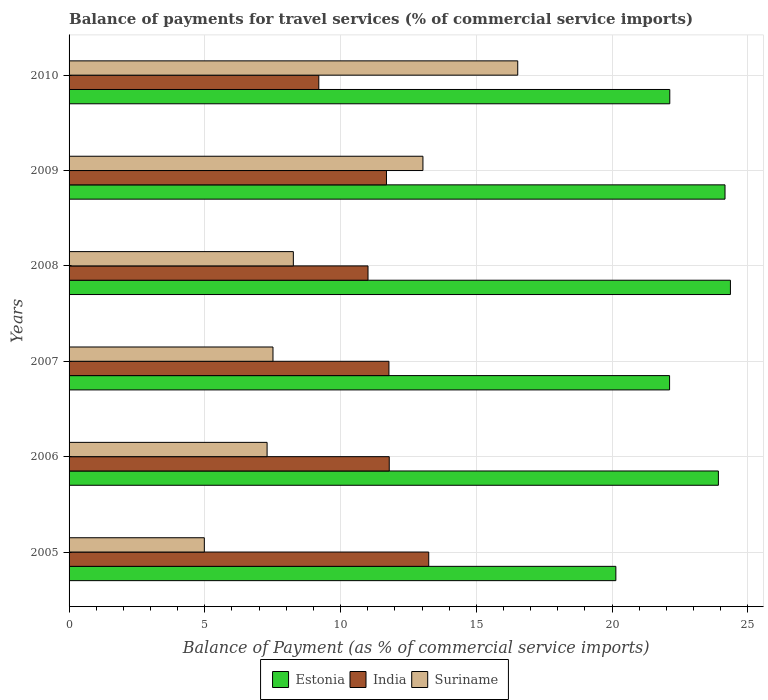Are the number of bars on each tick of the Y-axis equal?
Give a very brief answer. Yes. How many bars are there on the 4th tick from the bottom?
Ensure brevity in your answer.  3. What is the label of the 5th group of bars from the top?
Provide a short and direct response. 2006. What is the balance of payments for travel services in Suriname in 2007?
Ensure brevity in your answer.  7.51. Across all years, what is the maximum balance of payments for travel services in Estonia?
Offer a terse response. 24.36. Across all years, what is the minimum balance of payments for travel services in Suriname?
Provide a short and direct response. 4.98. In which year was the balance of payments for travel services in Suriname minimum?
Your answer should be very brief. 2005. What is the total balance of payments for travel services in Estonia in the graph?
Ensure brevity in your answer.  136.83. What is the difference between the balance of payments for travel services in Estonia in 2006 and that in 2007?
Make the answer very short. 1.8. What is the difference between the balance of payments for travel services in Suriname in 2006 and the balance of payments for travel services in Estonia in 2007?
Provide a short and direct response. -14.83. What is the average balance of payments for travel services in Suriname per year?
Your answer should be very brief. 9.6. In the year 2010, what is the difference between the balance of payments for travel services in Estonia and balance of payments for travel services in India?
Keep it short and to the point. 12.93. In how many years, is the balance of payments for travel services in Suriname greater than 15 %?
Give a very brief answer. 1. What is the ratio of the balance of payments for travel services in Suriname in 2007 to that in 2009?
Offer a very short reply. 0.58. Is the balance of payments for travel services in Suriname in 2009 less than that in 2010?
Provide a succinct answer. Yes. What is the difference between the highest and the second highest balance of payments for travel services in Suriname?
Your answer should be very brief. 3.49. What is the difference between the highest and the lowest balance of payments for travel services in Suriname?
Offer a very short reply. 11.54. Is the sum of the balance of payments for travel services in India in 2007 and 2008 greater than the maximum balance of payments for travel services in Suriname across all years?
Offer a terse response. Yes. What does the 3rd bar from the top in 2010 represents?
Offer a terse response. Estonia. What does the 3rd bar from the bottom in 2010 represents?
Give a very brief answer. Suriname. How many bars are there?
Offer a terse response. 18. Are all the bars in the graph horizontal?
Your answer should be compact. Yes. Does the graph contain grids?
Provide a short and direct response. Yes. Where does the legend appear in the graph?
Offer a terse response. Bottom center. What is the title of the graph?
Make the answer very short. Balance of payments for travel services (% of commercial service imports). What is the label or title of the X-axis?
Ensure brevity in your answer.  Balance of Payment (as % of commercial service imports). What is the label or title of the Y-axis?
Make the answer very short. Years. What is the Balance of Payment (as % of commercial service imports) of Estonia in 2005?
Ensure brevity in your answer.  20.14. What is the Balance of Payment (as % of commercial service imports) in India in 2005?
Keep it short and to the point. 13.25. What is the Balance of Payment (as % of commercial service imports) of Suriname in 2005?
Your answer should be compact. 4.98. What is the Balance of Payment (as % of commercial service imports) of Estonia in 2006?
Your answer should be compact. 23.92. What is the Balance of Payment (as % of commercial service imports) in India in 2006?
Offer a terse response. 11.79. What is the Balance of Payment (as % of commercial service imports) of Suriname in 2006?
Your answer should be compact. 7.29. What is the Balance of Payment (as % of commercial service imports) in Estonia in 2007?
Your answer should be compact. 22.12. What is the Balance of Payment (as % of commercial service imports) of India in 2007?
Offer a terse response. 11.78. What is the Balance of Payment (as % of commercial service imports) of Suriname in 2007?
Ensure brevity in your answer.  7.51. What is the Balance of Payment (as % of commercial service imports) of Estonia in 2008?
Give a very brief answer. 24.36. What is the Balance of Payment (as % of commercial service imports) of India in 2008?
Give a very brief answer. 11.01. What is the Balance of Payment (as % of commercial service imports) in Suriname in 2008?
Your answer should be compact. 8.26. What is the Balance of Payment (as % of commercial service imports) in Estonia in 2009?
Keep it short and to the point. 24.16. What is the Balance of Payment (as % of commercial service imports) in India in 2009?
Make the answer very short. 11.69. What is the Balance of Payment (as % of commercial service imports) in Suriname in 2009?
Ensure brevity in your answer.  13.03. What is the Balance of Payment (as % of commercial service imports) in Estonia in 2010?
Ensure brevity in your answer.  22.13. What is the Balance of Payment (as % of commercial service imports) of India in 2010?
Offer a terse response. 9.2. What is the Balance of Payment (as % of commercial service imports) in Suriname in 2010?
Give a very brief answer. 16.53. Across all years, what is the maximum Balance of Payment (as % of commercial service imports) in Estonia?
Ensure brevity in your answer.  24.36. Across all years, what is the maximum Balance of Payment (as % of commercial service imports) in India?
Provide a succinct answer. 13.25. Across all years, what is the maximum Balance of Payment (as % of commercial service imports) of Suriname?
Ensure brevity in your answer.  16.53. Across all years, what is the minimum Balance of Payment (as % of commercial service imports) of Estonia?
Your answer should be compact. 20.14. Across all years, what is the minimum Balance of Payment (as % of commercial service imports) in India?
Offer a terse response. 9.2. Across all years, what is the minimum Balance of Payment (as % of commercial service imports) in Suriname?
Your answer should be compact. 4.98. What is the total Balance of Payment (as % of commercial service imports) in Estonia in the graph?
Offer a terse response. 136.83. What is the total Balance of Payment (as % of commercial service imports) of India in the graph?
Offer a terse response. 68.72. What is the total Balance of Payment (as % of commercial service imports) in Suriname in the graph?
Provide a short and direct response. 57.61. What is the difference between the Balance of Payment (as % of commercial service imports) of Estonia in 2005 and that in 2006?
Provide a short and direct response. -3.78. What is the difference between the Balance of Payment (as % of commercial service imports) of India in 2005 and that in 2006?
Your response must be concise. 1.45. What is the difference between the Balance of Payment (as % of commercial service imports) in Suriname in 2005 and that in 2006?
Keep it short and to the point. -2.31. What is the difference between the Balance of Payment (as % of commercial service imports) in Estonia in 2005 and that in 2007?
Make the answer very short. -1.98. What is the difference between the Balance of Payment (as % of commercial service imports) of India in 2005 and that in 2007?
Provide a succinct answer. 1.47. What is the difference between the Balance of Payment (as % of commercial service imports) of Suriname in 2005 and that in 2007?
Your answer should be very brief. -2.53. What is the difference between the Balance of Payment (as % of commercial service imports) in Estonia in 2005 and that in 2008?
Your answer should be very brief. -4.22. What is the difference between the Balance of Payment (as % of commercial service imports) of India in 2005 and that in 2008?
Your answer should be compact. 2.24. What is the difference between the Balance of Payment (as % of commercial service imports) of Suriname in 2005 and that in 2008?
Ensure brevity in your answer.  -3.28. What is the difference between the Balance of Payment (as % of commercial service imports) in Estonia in 2005 and that in 2009?
Your answer should be very brief. -4.02. What is the difference between the Balance of Payment (as % of commercial service imports) of India in 2005 and that in 2009?
Ensure brevity in your answer.  1.56. What is the difference between the Balance of Payment (as % of commercial service imports) of Suriname in 2005 and that in 2009?
Provide a succinct answer. -8.05. What is the difference between the Balance of Payment (as % of commercial service imports) in Estonia in 2005 and that in 2010?
Provide a short and direct response. -1.99. What is the difference between the Balance of Payment (as % of commercial service imports) of India in 2005 and that in 2010?
Give a very brief answer. 4.05. What is the difference between the Balance of Payment (as % of commercial service imports) in Suriname in 2005 and that in 2010?
Offer a very short reply. -11.54. What is the difference between the Balance of Payment (as % of commercial service imports) in Estonia in 2006 and that in 2007?
Offer a terse response. 1.8. What is the difference between the Balance of Payment (as % of commercial service imports) in India in 2006 and that in 2007?
Provide a succinct answer. 0.01. What is the difference between the Balance of Payment (as % of commercial service imports) of Suriname in 2006 and that in 2007?
Make the answer very short. -0.22. What is the difference between the Balance of Payment (as % of commercial service imports) in Estonia in 2006 and that in 2008?
Keep it short and to the point. -0.44. What is the difference between the Balance of Payment (as % of commercial service imports) of India in 2006 and that in 2008?
Offer a terse response. 0.78. What is the difference between the Balance of Payment (as % of commercial service imports) in Suriname in 2006 and that in 2008?
Your answer should be very brief. -0.97. What is the difference between the Balance of Payment (as % of commercial service imports) of Estonia in 2006 and that in 2009?
Give a very brief answer. -0.24. What is the difference between the Balance of Payment (as % of commercial service imports) of India in 2006 and that in 2009?
Keep it short and to the point. 0.1. What is the difference between the Balance of Payment (as % of commercial service imports) in Suriname in 2006 and that in 2009?
Offer a very short reply. -5.74. What is the difference between the Balance of Payment (as % of commercial service imports) of Estonia in 2006 and that in 2010?
Provide a succinct answer. 1.79. What is the difference between the Balance of Payment (as % of commercial service imports) of India in 2006 and that in 2010?
Ensure brevity in your answer.  2.59. What is the difference between the Balance of Payment (as % of commercial service imports) in Suriname in 2006 and that in 2010?
Offer a terse response. -9.23. What is the difference between the Balance of Payment (as % of commercial service imports) in Estonia in 2007 and that in 2008?
Your response must be concise. -2.24. What is the difference between the Balance of Payment (as % of commercial service imports) of India in 2007 and that in 2008?
Your answer should be very brief. 0.77. What is the difference between the Balance of Payment (as % of commercial service imports) in Suriname in 2007 and that in 2008?
Ensure brevity in your answer.  -0.75. What is the difference between the Balance of Payment (as % of commercial service imports) of Estonia in 2007 and that in 2009?
Your answer should be very brief. -2.04. What is the difference between the Balance of Payment (as % of commercial service imports) in India in 2007 and that in 2009?
Your response must be concise. 0.09. What is the difference between the Balance of Payment (as % of commercial service imports) of Suriname in 2007 and that in 2009?
Provide a short and direct response. -5.52. What is the difference between the Balance of Payment (as % of commercial service imports) of Estonia in 2007 and that in 2010?
Your answer should be compact. -0.01. What is the difference between the Balance of Payment (as % of commercial service imports) in India in 2007 and that in 2010?
Keep it short and to the point. 2.58. What is the difference between the Balance of Payment (as % of commercial service imports) in Suriname in 2007 and that in 2010?
Your answer should be very brief. -9.02. What is the difference between the Balance of Payment (as % of commercial service imports) of Estonia in 2008 and that in 2009?
Offer a very short reply. 0.2. What is the difference between the Balance of Payment (as % of commercial service imports) of India in 2008 and that in 2009?
Give a very brief answer. -0.68. What is the difference between the Balance of Payment (as % of commercial service imports) of Suriname in 2008 and that in 2009?
Ensure brevity in your answer.  -4.77. What is the difference between the Balance of Payment (as % of commercial service imports) of Estonia in 2008 and that in 2010?
Your response must be concise. 2.23. What is the difference between the Balance of Payment (as % of commercial service imports) in India in 2008 and that in 2010?
Give a very brief answer. 1.81. What is the difference between the Balance of Payment (as % of commercial service imports) of Suriname in 2008 and that in 2010?
Make the answer very short. -8.27. What is the difference between the Balance of Payment (as % of commercial service imports) of Estonia in 2009 and that in 2010?
Give a very brief answer. 2.03. What is the difference between the Balance of Payment (as % of commercial service imports) of India in 2009 and that in 2010?
Offer a terse response. 2.49. What is the difference between the Balance of Payment (as % of commercial service imports) of Suriname in 2009 and that in 2010?
Offer a very short reply. -3.49. What is the difference between the Balance of Payment (as % of commercial service imports) of Estonia in 2005 and the Balance of Payment (as % of commercial service imports) of India in 2006?
Your response must be concise. 8.35. What is the difference between the Balance of Payment (as % of commercial service imports) in Estonia in 2005 and the Balance of Payment (as % of commercial service imports) in Suriname in 2006?
Provide a succinct answer. 12.85. What is the difference between the Balance of Payment (as % of commercial service imports) of India in 2005 and the Balance of Payment (as % of commercial service imports) of Suriname in 2006?
Your response must be concise. 5.95. What is the difference between the Balance of Payment (as % of commercial service imports) of Estonia in 2005 and the Balance of Payment (as % of commercial service imports) of India in 2007?
Make the answer very short. 8.36. What is the difference between the Balance of Payment (as % of commercial service imports) in Estonia in 2005 and the Balance of Payment (as % of commercial service imports) in Suriname in 2007?
Your answer should be compact. 12.63. What is the difference between the Balance of Payment (as % of commercial service imports) of India in 2005 and the Balance of Payment (as % of commercial service imports) of Suriname in 2007?
Make the answer very short. 5.74. What is the difference between the Balance of Payment (as % of commercial service imports) of Estonia in 2005 and the Balance of Payment (as % of commercial service imports) of India in 2008?
Your response must be concise. 9.13. What is the difference between the Balance of Payment (as % of commercial service imports) of Estonia in 2005 and the Balance of Payment (as % of commercial service imports) of Suriname in 2008?
Offer a terse response. 11.88. What is the difference between the Balance of Payment (as % of commercial service imports) in India in 2005 and the Balance of Payment (as % of commercial service imports) in Suriname in 2008?
Keep it short and to the point. 4.99. What is the difference between the Balance of Payment (as % of commercial service imports) of Estonia in 2005 and the Balance of Payment (as % of commercial service imports) of India in 2009?
Your answer should be very brief. 8.45. What is the difference between the Balance of Payment (as % of commercial service imports) in Estonia in 2005 and the Balance of Payment (as % of commercial service imports) in Suriname in 2009?
Offer a terse response. 7.11. What is the difference between the Balance of Payment (as % of commercial service imports) of India in 2005 and the Balance of Payment (as % of commercial service imports) of Suriname in 2009?
Provide a succinct answer. 0.21. What is the difference between the Balance of Payment (as % of commercial service imports) in Estonia in 2005 and the Balance of Payment (as % of commercial service imports) in India in 2010?
Ensure brevity in your answer.  10.94. What is the difference between the Balance of Payment (as % of commercial service imports) in Estonia in 2005 and the Balance of Payment (as % of commercial service imports) in Suriname in 2010?
Make the answer very short. 3.61. What is the difference between the Balance of Payment (as % of commercial service imports) in India in 2005 and the Balance of Payment (as % of commercial service imports) in Suriname in 2010?
Offer a very short reply. -3.28. What is the difference between the Balance of Payment (as % of commercial service imports) of Estonia in 2006 and the Balance of Payment (as % of commercial service imports) of India in 2007?
Ensure brevity in your answer.  12.14. What is the difference between the Balance of Payment (as % of commercial service imports) of Estonia in 2006 and the Balance of Payment (as % of commercial service imports) of Suriname in 2007?
Your answer should be compact. 16.41. What is the difference between the Balance of Payment (as % of commercial service imports) in India in 2006 and the Balance of Payment (as % of commercial service imports) in Suriname in 2007?
Offer a very short reply. 4.28. What is the difference between the Balance of Payment (as % of commercial service imports) in Estonia in 2006 and the Balance of Payment (as % of commercial service imports) in India in 2008?
Provide a short and direct response. 12.91. What is the difference between the Balance of Payment (as % of commercial service imports) in Estonia in 2006 and the Balance of Payment (as % of commercial service imports) in Suriname in 2008?
Your answer should be compact. 15.66. What is the difference between the Balance of Payment (as % of commercial service imports) of India in 2006 and the Balance of Payment (as % of commercial service imports) of Suriname in 2008?
Your response must be concise. 3.53. What is the difference between the Balance of Payment (as % of commercial service imports) in Estonia in 2006 and the Balance of Payment (as % of commercial service imports) in India in 2009?
Offer a very short reply. 12.23. What is the difference between the Balance of Payment (as % of commercial service imports) in Estonia in 2006 and the Balance of Payment (as % of commercial service imports) in Suriname in 2009?
Your answer should be very brief. 10.88. What is the difference between the Balance of Payment (as % of commercial service imports) in India in 2006 and the Balance of Payment (as % of commercial service imports) in Suriname in 2009?
Provide a succinct answer. -1.24. What is the difference between the Balance of Payment (as % of commercial service imports) of Estonia in 2006 and the Balance of Payment (as % of commercial service imports) of India in 2010?
Provide a succinct answer. 14.72. What is the difference between the Balance of Payment (as % of commercial service imports) in Estonia in 2006 and the Balance of Payment (as % of commercial service imports) in Suriname in 2010?
Ensure brevity in your answer.  7.39. What is the difference between the Balance of Payment (as % of commercial service imports) in India in 2006 and the Balance of Payment (as % of commercial service imports) in Suriname in 2010?
Ensure brevity in your answer.  -4.73. What is the difference between the Balance of Payment (as % of commercial service imports) of Estonia in 2007 and the Balance of Payment (as % of commercial service imports) of India in 2008?
Your response must be concise. 11.11. What is the difference between the Balance of Payment (as % of commercial service imports) of Estonia in 2007 and the Balance of Payment (as % of commercial service imports) of Suriname in 2008?
Offer a very short reply. 13.86. What is the difference between the Balance of Payment (as % of commercial service imports) in India in 2007 and the Balance of Payment (as % of commercial service imports) in Suriname in 2008?
Provide a short and direct response. 3.52. What is the difference between the Balance of Payment (as % of commercial service imports) in Estonia in 2007 and the Balance of Payment (as % of commercial service imports) in India in 2009?
Offer a very short reply. 10.43. What is the difference between the Balance of Payment (as % of commercial service imports) in Estonia in 2007 and the Balance of Payment (as % of commercial service imports) in Suriname in 2009?
Provide a short and direct response. 9.08. What is the difference between the Balance of Payment (as % of commercial service imports) in India in 2007 and the Balance of Payment (as % of commercial service imports) in Suriname in 2009?
Offer a very short reply. -1.25. What is the difference between the Balance of Payment (as % of commercial service imports) in Estonia in 2007 and the Balance of Payment (as % of commercial service imports) in India in 2010?
Ensure brevity in your answer.  12.92. What is the difference between the Balance of Payment (as % of commercial service imports) in Estonia in 2007 and the Balance of Payment (as % of commercial service imports) in Suriname in 2010?
Offer a very short reply. 5.59. What is the difference between the Balance of Payment (as % of commercial service imports) in India in 2007 and the Balance of Payment (as % of commercial service imports) in Suriname in 2010?
Offer a very short reply. -4.74. What is the difference between the Balance of Payment (as % of commercial service imports) in Estonia in 2008 and the Balance of Payment (as % of commercial service imports) in India in 2009?
Your response must be concise. 12.67. What is the difference between the Balance of Payment (as % of commercial service imports) in Estonia in 2008 and the Balance of Payment (as % of commercial service imports) in Suriname in 2009?
Give a very brief answer. 11.33. What is the difference between the Balance of Payment (as % of commercial service imports) in India in 2008 and the Balance of Payment (as % of commercial service imports) in Suriname in 2009?
Your response must be concise. -2.02. What is the difference between the Balance of Payment (as % of commercial service imports) of Estonia in 2008 and the Balance of Payment (as % of commercial service imports) of India in 2010?
Your answer should be very brief. 15.16. What is the difference between the Balance of Payment (as % of commercial service imports) of Estonia in 2008 and the Balance of Payment (as % of commercial service imports) of Suriname in 2010?
Your answer should be compact. 7.83. What is the difference between the Balance of Payment (as % of commercial service imports) in India in 2008 and the Balance of Payment (as % of commercial service imports) in Suriname in 2010?
Offer a terse response. -5.51. What is the difference between the Balance of Payment (as % of commercial service imports) in Estonia in 2009 and the Balance of Payment (as % of commercial service imports) in India in 2010?
Make the answer very short. 14.96. What is the difference between the Balance of Payment (as % of commercial service imports) of Estonia in 2009 and the Balance of Payment (as % of commercial service imports) of Suriname in 2010?
Give a very brief answer. 7.64. What is the difference between the Balance of Payment (as % of commercial service imports) of India in 2009 and the Balance of Payment (as % of commercial service imports) of Suriname in 2010?
Offer a very short reply. -4.83. What is the average Balance of Payment (as % of commercial service imports) in Estonia per year?
Your response must be concise. 22.8. What is the average Balance of Payment (as % of commercial service imports) of India per year?
Your response must be concise. 11.45. What is the average Balance of Payment (as % of commercial service imports) in Suriname per year?
Your answer should be compact. 9.6. In the year 2005, what is the difference between the Balance of Payment (as % of commercial service imports) of Estonia and Balance of Payment (as % of commercial service imports) of India?
Give a very brief answer. 6.89. In the year 2005, what is the difference between the Balance of Payment (as % of commercial service imports) of Estonia and Balance of Payment (as % of commercial service imports) of Suriname?
Your answer should be compact. 15.16. In the year 2005, what is the difference between the Balance of Payment (as % of commercial service imports) in India and Balance of Payment (as % of commercial service imports) in Suriname?
Give a very brief answer. 8.27. In the year 2006, what is the difference between the Balance of Payment (as % of commercial service imports) in Estonia and Balance of Payment (as % of commercial service imports) in India?
Provide a succinct answer. 12.12. In the year 2006, what is the difference between the Balance of Payment (as % of commercial service imports) in Estonia and Balance of Payment (as % of commercial service imports) in Suriname?
Keep it short and to the point. 16.62. In the year 2006, what is the difference between the Balance of Payment (as % of commercial service imports) of India and Balance of Payment (as % of commercial service imports) of Suriname?
Keep it short and to the point. 4.5. In the year 2007, what is the difference between the Balance of Payment (as % of commercial service imports) of Estonia and Balance of Payment (as % of commercial service imports) of India?
Offer a terse response. 10.34. In the year 2007, what is the difference between the Balance of Payment (as % of commercial service imports) of Estonia and Balance of Payment (as % of commercial service imports) of Suriname?
Offer a terse response. 14.61. In the year 2007, what is the difference between the Balance of Payment (as % of commercial service imports) of India and Balance of Payment (as % of commercial service imports) of Suriname?
Your answer should be very brief. 4.27. In the year 2008, what is the difference between the Balance of Payment (as % of commercial service imports) of Estonia and Balance of Payment (as % of commercial service imports) of India?
Keep it short and to the point. 13.35. In the year 2008, what is the difference between the Balance of Payment (as % of commercial service imports) in Estonia and Balance of Payment (as % of commercial service imports) in Suriname?
Your answer should be very brief. 16.1. In the year 2008, what is the difference between the Balance of Payment (as % of commercial service imports) of India and Balance of Payment (as % of commercial service imports) of Suriname?
Keep it short and to the point. 2.75. In the year 2009, what is the difference between the Balance of Payment (as % of commercial service imports) of Estonia and Balance of Payment (as % of commercial service imports) of India?
Provide a succinct answer. 12.47. In the year 2009, what is the difference between the Balance of Payment (as % of commercial service imports) of Estonia and Balance of Payment (as % of commercial service imports) of Suriname?
Your answer should be compact. 11.13. In the year 2009, what is the difference between the Balance of Payment (as % of commercial service imports) of India and Balance of Payment (as % of commercial service imports) of Suriname?
Provide a short and direct response. -1.34. In the year 2010, what is the difference between the Balance of Payment (as % of commercial service imports) of Estonia and Balance of Payment (as % of commercial service imports) of India?
Keep it short and to the point. 12.93. In the year 2010, what is the difference between the Balance of Payment (as % of commercial service imports) in Estonia and Balance of Payment (as % of commercial service imports) in Suriname?
Keep it short and to the point. 5.6. In the year 2010, what is the difference between the Balance of Payment (as % of commercial service imports) in India and Balance of Payment (as % of commercial service imports) in Suriname?
Ensure brevity in your answer.  -7.33. What is the ratio of the Balance of Payment (as % of commercial service imports) in Estonia in 2005 to that in 2006?
Your answer should be compact. 0.84. What is the ratio of the Balance of Payment (as % of commercial service imports) of India in 2005 to that in 2006?
Provide a short and direct response. 1.12. What is the ratio of the Balance of Payment (as % of commercial service imports) of Suriname in 2005 to that in 2006?
Offer a terse response. 0.68. What is the ratio of the Balance of Payment (as % of commercial service imports) in Estonia in 2005 to that in 2007?
Your response must be concise. 0.91. What is the ratio of the Balance of Payment (as % of commercial service imports) of India in 2005 to that in 2007?
Keep it short and to the point. 1.12. What is the ratio of the Balance of Payment (as % of commercial service imports) in Suriname in 2005 to that in 2007?
Your answer should be very brief. 0.66. What is the ratio of the Balance of Payment (as % of commercial service imports) of Estonia in 2005 to that in 2008?
Give a very brief answer. 0.83. What is the ratio of the Balance of Payment (as % of commercial service imports) of India in 2005 to that in 2008?
Ensure brevity in your answer.  1.2. What is the ratio of the Balance of Payment (as % of commercial service imports) of Suriname in 2005 to that in 2008?
Keep it short and to the point. 0.6. What is the ratio of the Balance of Payment (as % of commercial service imports) in Estonia in 2005 to that in 2009?
Provide a succinct answer. 0.83. What is the ratio of the Balance of Payment (as % of commercial service imports) in India in 2005 to that in 2009?
Your answer should be compact. 1.13. What is the ratio of the Balance of Payment (as % of commercial service imports) in Suriname in 2005 to that in 2009?
Your response must be concise. 0.38. What is the ratio of the Balance of Payment (as % of commercial service imports) of Estonia in 2005 to that in 2010?
Your answer should be very brief. 0.91. What is the ratio of the Balance of Payment (as % of commercial service imports) in India in 2005 to that in 2010?
Your response must be concise. 1.44. What is the ratio of the Balance of Payment (as % of commercial service imports) of Suriname in 2005 to that in 2010?
Provide a succinct answer. 0.3. What is the ratio of the Balance of Payment (as % of commercial service imports) in Estonia in 2006 to that in 2007?
Keep it short and to the point. 1.08. What is the ratio of the Balance of Payment (as % of commercial service imports) of India in 2006 to that in 2007?
Provide a short and direct response. 1. What is the ratio of the Balance of Payment (as % of commercial service imports) in Suriname in 2006 to that in 2007?
Give a very brief answer. 0.97. What is the ratio of the Balance of Payment (as % of commercial service imports) in Estonia in 2006 to that in 2008?
Offer a terse response. 0.98. What is the ratio of the Balance of Payment (as % of commercial service imports) of India in 2006 to that in 2008?
Your answer should be compact. 1.07. What is the ratio of the Balance of Payment (as % of commercial service imports) of Suriname in 2006 to that in 2008?
Offer a terse response. 0.88. What is the ratio of the Balance of Payment (as % of commercial service imports) of Estonia in 2006 to that in 2009?
Your response must be concise. 0.99. What is the ratio of the Balance of Payment (as % of commercial service imports) of India in 2006 to that in 2009?
Ensure brevity in your answer.  1.01. What is the ratio of the Balance of Payment (as % of commercial service imports) in Suriname in 2006 to that in 2009?
Your response must be concise. 0.56. What is the ratio of the Balance of Payment (as % of commercial service imports) in Estonia in 2006 to that in 2010?
Make the answer very short. 1.08. What is the ratio of the Balance of Payment (as % of commercial service imports) of India in 2006 to that in 2010?
Your answer should be very brief. 1.28. What is the ratio of the Balance of Payment (as % of commercial service imports) in Suriname in 2006 to that in 2010?
Provide a short and direct response. 0.44. What is the ratio of the Balance of Payment (as % of commercial service imports) of Estonia in 2007 to that in 2008?
Your answer should be compact. 0.91. What is the ratio of the Balance of Payment (as % of commercial service imports) in India in 2007 to that in 2008?
Make the answer very short. 1.07. What is the ratio of the Balance of Payment (as % of commercial service imports) of Suriname in 2007 to that in 2008?
Keep it short and to the point. 0.91. What is the ratio of the Balance of Payment (as % of commercial service imports) of Estonia in 2007 to that in 2009?
Provide a short and direct response. 0.92. What is the ratio of the Balance of Payment (as % of commercial service imports) of Suriname in 2007 to that in 2009?
Make the answer very short. 0.58. What is the ratio of the Balance of Payment (as % of commercial service imports) of India in 2007 to that in 2010?
Ensure brevity in your answer.  1.28. What is the ratio of the Balance of Payment (as % of commercial service imports) in Suriname in 2007 to that in 2010?
Your answer should be compact. 0.45. What is the ratio of the Balance of Payment (as % of commercial service imports) of Estonia in 2008 to that in 2009?
Your answer should be very brief. 1.01. What is the ratio of the Balance of Payment (as % of commercial service imports) in India in 2008 to that in 2009?
Your answer should be compact. 0.94. What is the ratio of the Balance of Payment (as % of commercial service imports) in Suriname in 2008 to that in 2009?
Ensure brevity in your answer.  0.63. What is the ratio of the Balance of Payment (as % of commercial service imports) of Estonia in 2008 to that in 2010?
Give a very brief answer. 1.1. What is the ratio of the Balance of Payment (as % of commercial service imports) of India in 2008 to that in 2010?
Provide a short and direct response. 1.2. What is the ratio of the Balance of Payment (as % of commercial service imports) in Suriname in 2008 to that in 2010?
Keep it short and to the point. 0.5. What is the ratio of the Balance of Payment (as % of commercial service imports) in Estonia in 2009 to that in 2010?
Provide a succinct answer. 1.09. What is the ratio of the Balance of Payment (as % of commercial service imports) in India in 2009 to that in 2010?
Keep it short and to the point. 1.27. What is the ratio of the Balance of Payment (as % of commercial service imports) in Suriname in 2009 to that in 2010?
Offer a very short reply. 0.79. What is the difference between the highest and the second highest Balance of Payment (as % of commercial service imports) of Estonia?
Give a very brief answer. 0.2. What is the difference between the highest and the second highest Balance of Payment (as % of commercial service imports) of India?
Your answer should be very brief. 1.45. What is the difference between the highest and the second highest Balance of Payment (as % of commercial service imports) in Suriname?
Your response must be concise. 3.49. What is the difference between the highest and the lowest Balance of Payment (as % of commercial service imports) in Estonia?
Make the answer very short. 4.22. What is the difference between the highest and the lowest Balance of Payment (as % of commercial service imports) in India?
Your answer should be very brief. 4.05. What is the difference between the highest and the lowest Balance of Payment (as % of commercial service imports) in Suriname?
Offer a terse response. 11.54. 